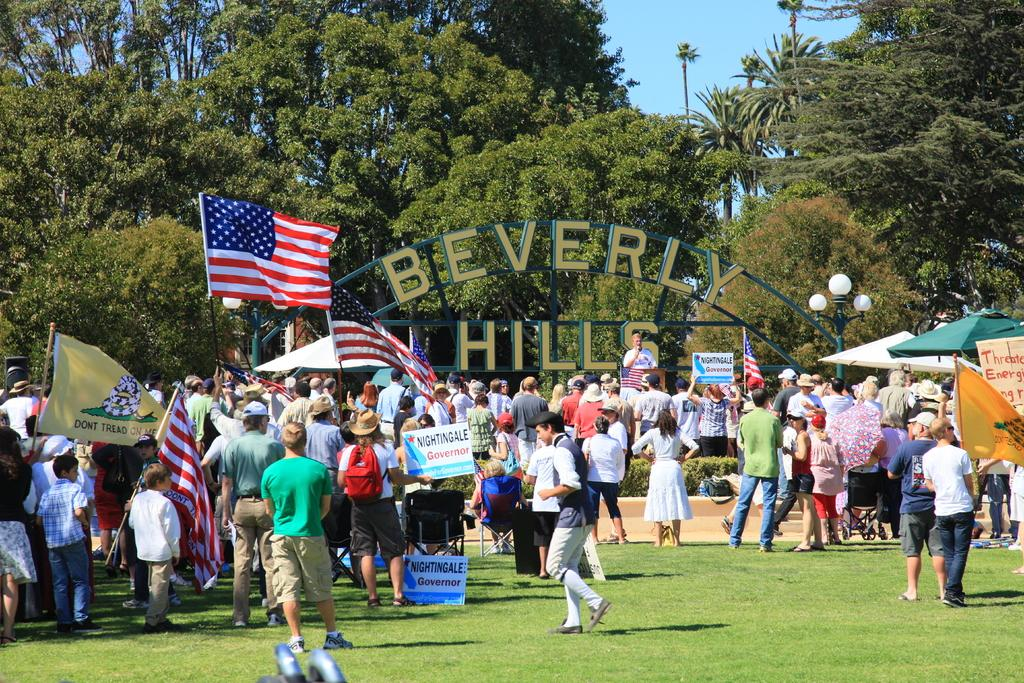What type of structure is present in the image? There is a name arch in the image. What type of natural elements can be seen in the image? There are trees in the image. What part of the natural environment is visible in the image? The sky is visible in the image. What type of man-made structures are present in the image? There are street poles and flag posts in the image. What type of lighting is present in the image? There are street lights in the image. What type of objects are present for shade or decoration? There are parasols and flags in the image. Are there any people present in the image? Yes, there are persons standing on the ground in the image. Where are the cherries hanging from in the image? There are no cherries present in the image. What type of observation can be made about the persons standing on the ground in the image? The image does not provide any information about the thoughts or observations of the persons standing on the ground. What type of jewelry is visible on the persons standing on the ground in the image? There is no jewelry, such as a locket, visible on the persons standing on the ground in the image. 